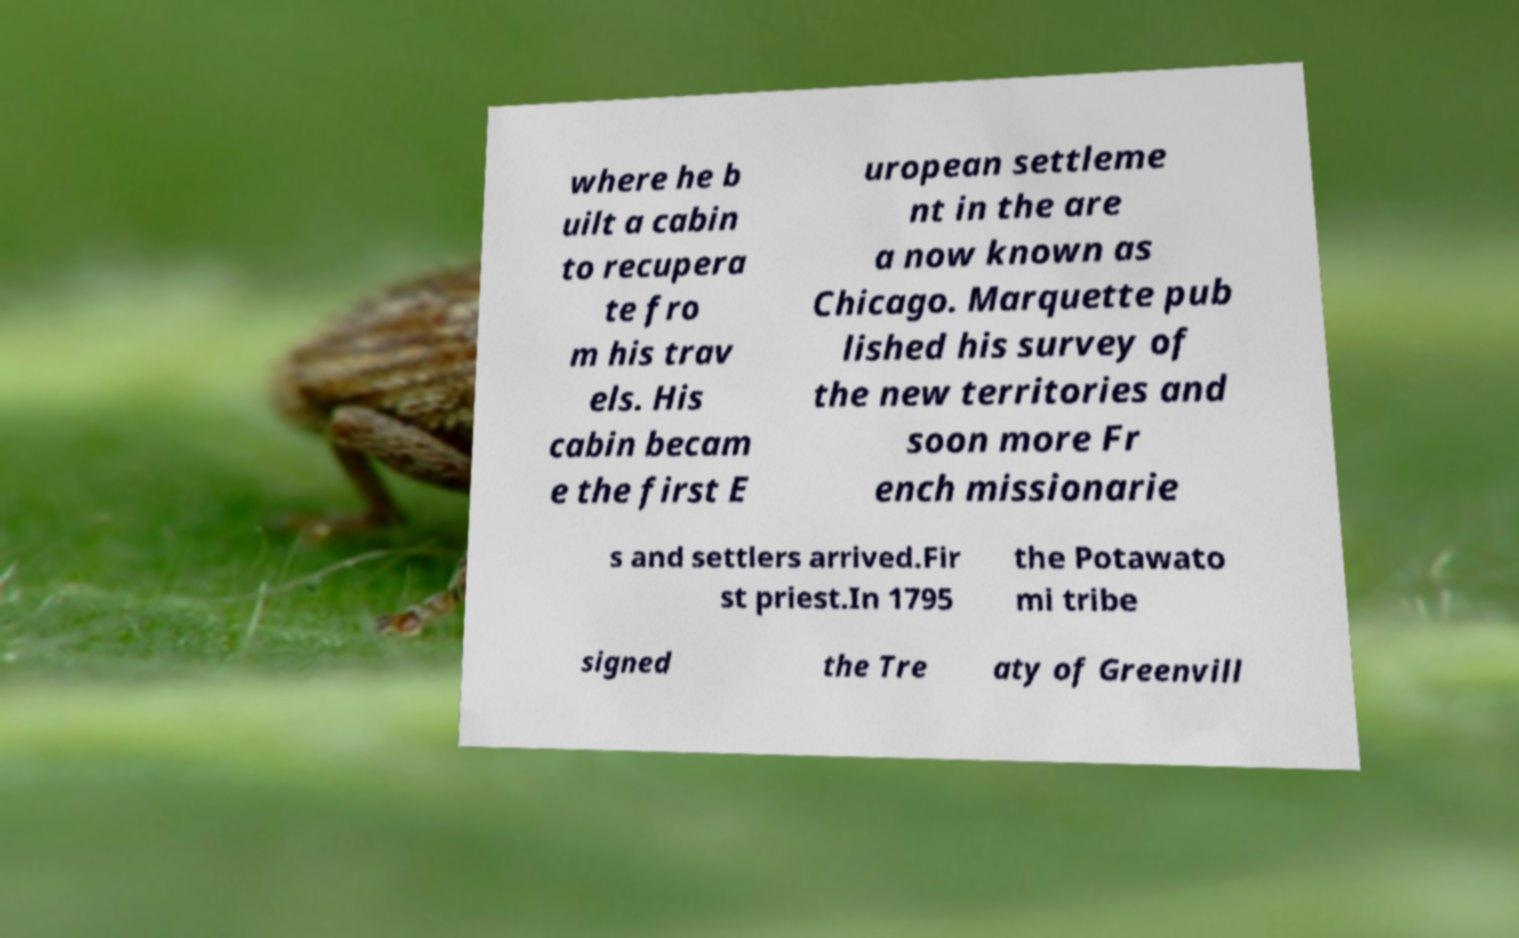I need the written content from this picture converted into text. Can you do that? where he b uilt a cabin to recupera te fro m his trav els. His cabin becam e the first E uropean settleme nt in the are a now known as Chicago. Marquette pub lished his survey of the new territories and soon more Fr ench missionarie s and settlers arrived.Fir st priest.In 1795 the Potawato mi tribe signed the Tre aty of Greenvill 